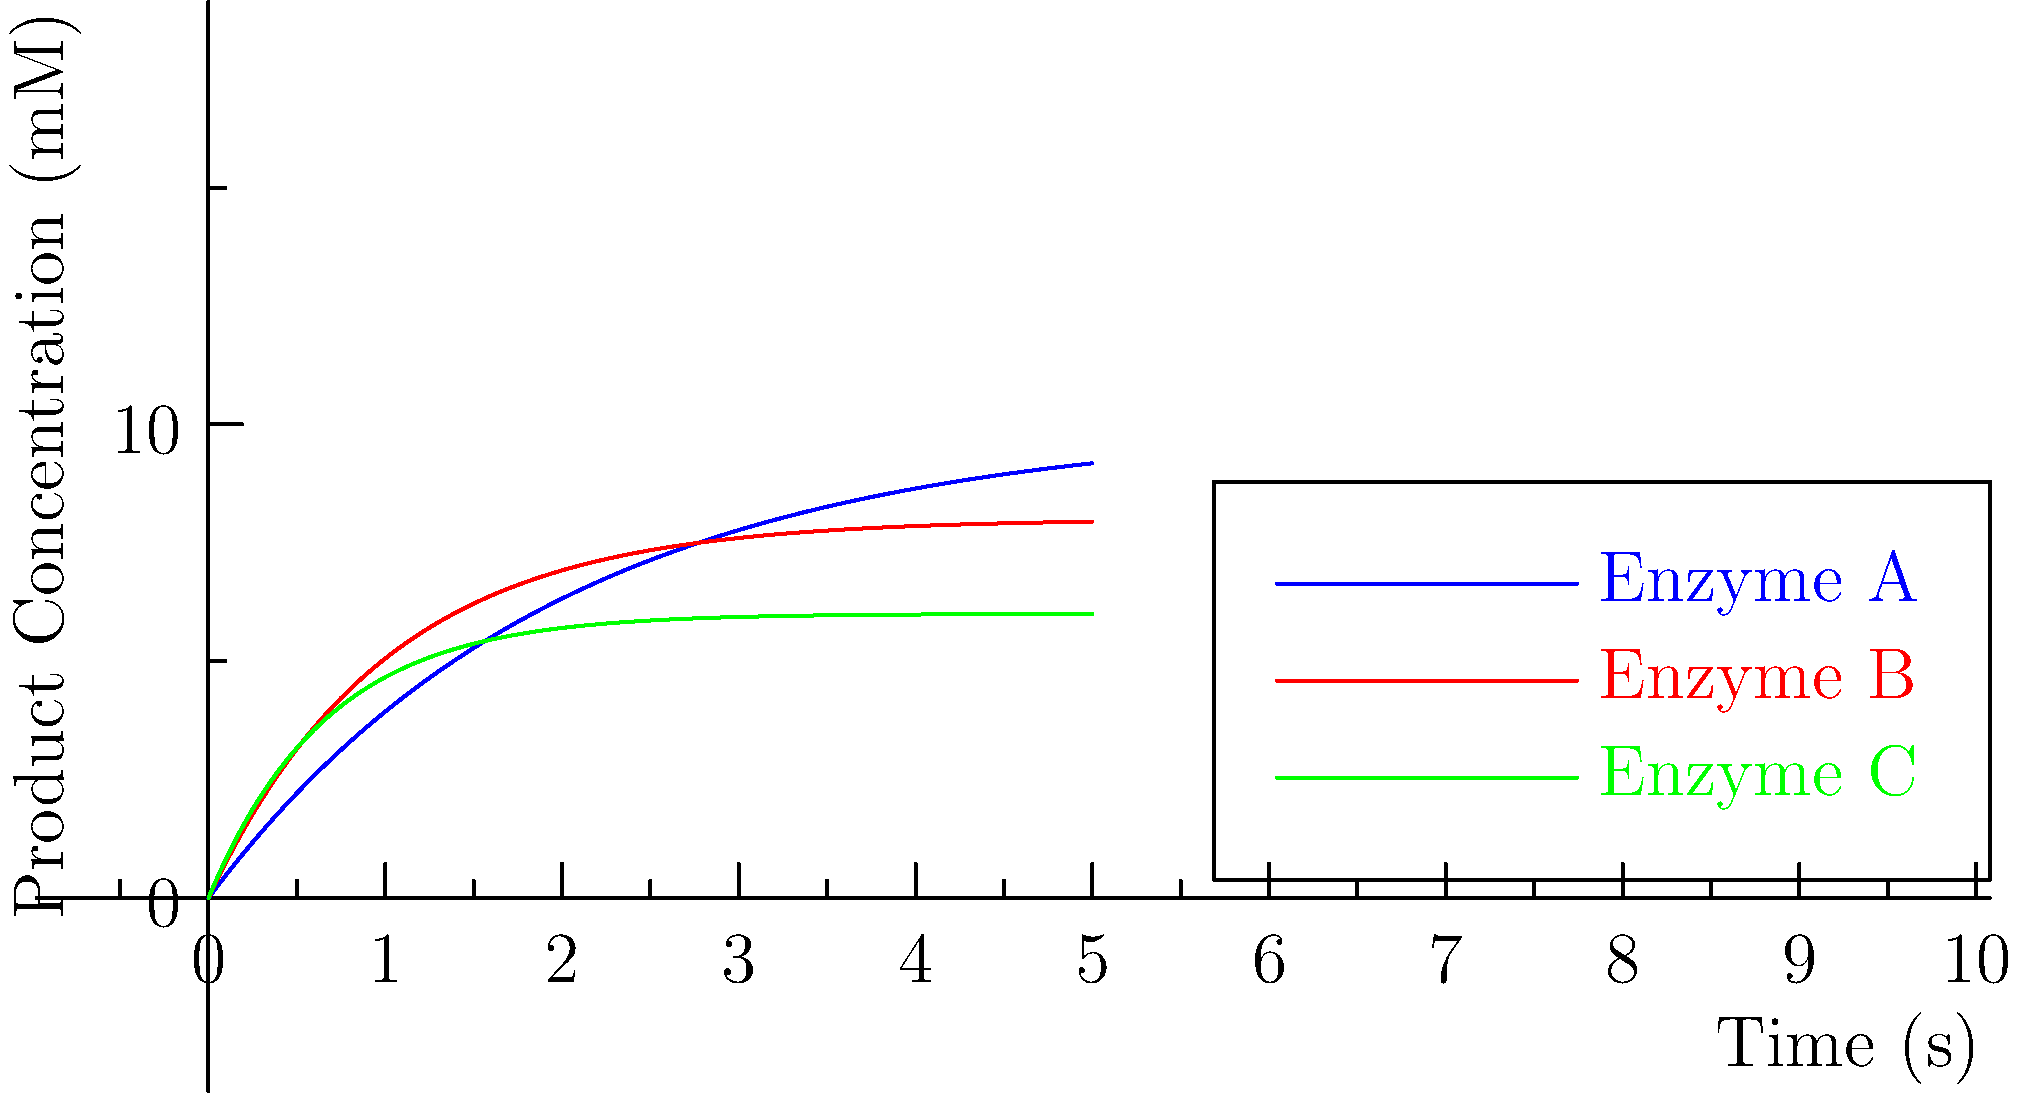Based on the graph showing the reaction kinetics of three different enzymes (A, B, and C), which enzyme is likely to have the highest $k_{cat}$ (turnover number) value? To determine which enzyme has the highest $k_{cat}$ value, we need to analyze the reaction kinetics curves:

1. The $k_{cat}$ value, also known as the turnover number, represents the maximum number of substrate molecules converted to product per enzyme molecule per unit time.

2. In the graph, the y-axis represents product concentration, and the x-axis represents time. The steeper the initial slope and the quicker the curve reaches its plateau, the higher the $k_{cat}$ value.

3. Analyzing each enzyme:
   - Enzyme A (blue): Has the steepest initial slope and reaches the highest plateau quickly.
   - Enzyme B (red): Has a moderate initial slope and reaches its plateau at an intermediate rate.
   - Enzyme C (green): Has the least steep initial slope and takes the longest to reach its plateau.

4. The steeper initial slope of Enzyme A indicates that it converts substrate to product faster than the other enzymes, suggesting a higher $k_{cat}$ value.

5. Additionally, Enzyme A reaches the highest product concentration, further supporting its superior catalytic efficiency.

Therefore, based on the graphical representation of reaction kinetics, Enzyme A is likely to have the highest $k_{cat}$ value.
Answer: Enzyme A 